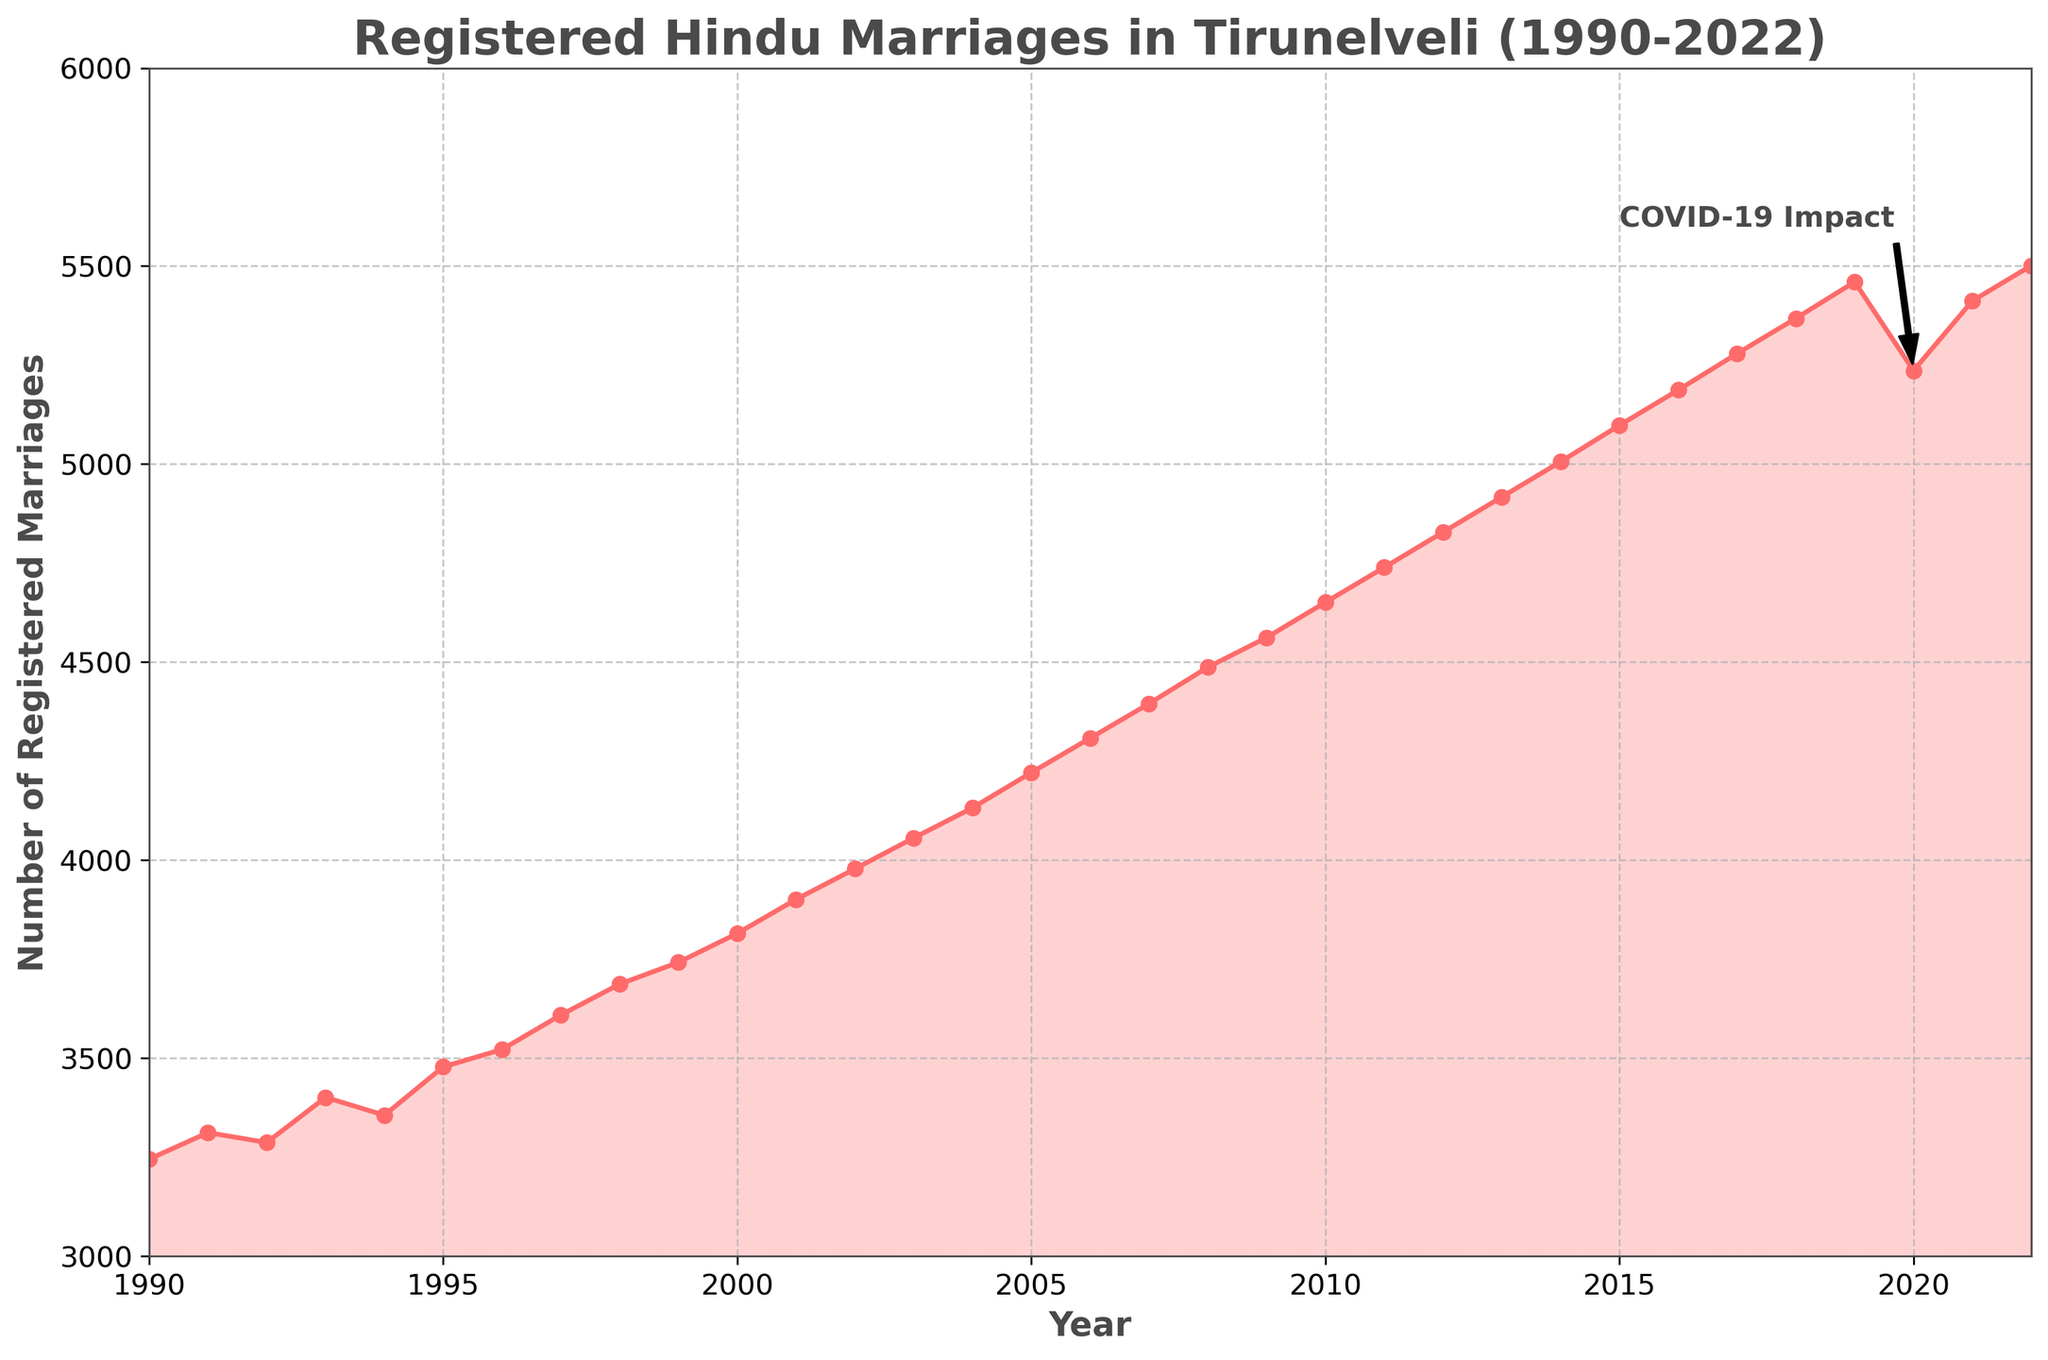What was the trend of registered Hindu marriages from 1990 to 2022 in Tirunelveli? By looking at the line chart, the trend can be seen as the overall number of registered Hindu marriages increased from 1990 to 2022, with a noticeable drop around 2020 due to the COVID-19 impact.
Answer: The trend was an overall increase with a drop in 2020 How did registered Hindu marriages change from 2019 to 2020? The number of registered Hindu marriages decreased from 2019 (5460 marriages) to 2020 (5236 marriages). This period corresponds with the COVID-19 pandemic, which likely impacted the number of marriages.
Answer: Decreased Which year witnessed the highest number of registered Hindu marriages? From the figure, 2022 has the highest number of registered Hindu marriages at 5501.
Answer: 2022 Compare the number of registered Hindu marriages in 1995 and 2005. In 1995, there were 3478 registered Hindu marriages. In 2005, there were 4221. By subtracting the number in 1995 from the number in 2005, we can see that the marriages increased. 4221 - 3478 = 743.
Answer: 2005 had 743 more marriages than 1995 What is the visible annotation in the figure, and what does it signify? The annotation is "COVID-19 Impact" pointing at the year 2020 where there is a noticeable drop in the number of registered marriages. This suggests that the COVID-19 pandemic had an impact on the number of registered Hindu marriages.
Answer: "COVID-19 Impact" Estimate the average yearly increase in registered Hindu marriages from 1990 to 2022 (excluding 2020). To estimate the average yearly increase: first calculate the total increase from 1990 to 2022 excluding 2020:
Total increase from 1990 to 2022 = 5501 - 3245 = 2256.
Number of years excluding 2020 = 2022 - 1990 = 32 years.
Average yearly increase = 2256 / 32 ≈ 70.5.
Answer: Approximately 70.5 per year Between which consecutive years was the largest increase in registered Hindu marriages observed? By analyzing the figure, the largest increase is observed between the years 2020 (5236 marriages) and 2021 (5412 marriages), with an increase of 176 marriages.
Answer: 2020-2021 What visual feature indicates the COVID-19 impact in the line chart? The COVID-19 impact is visually indicated by an annotation near a noticeable drop in the line for the year 2020. Following this year, there is an arrow pointing from the annotation text "COVID-19 Impact" to that point on the line.
Answer: Annotation and Arrow How does the number of registered Hindu marriages in the year 2000 compare to the year 2010? In 2000, there were 3815 registered Hindu marriages and in 2010, there were 4651. By comparing, it's clear that the number has increased. 4651 - 3815 = 836 marriages more in 2010 than in 2000.
Answer: 2010 had 836 more marriages than 2000 